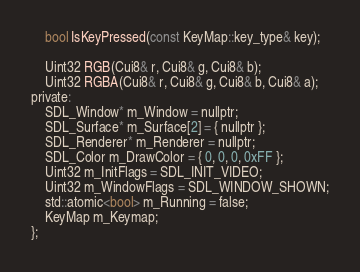Convert code to text. <code><loc_0><loc_0><loc_500><loc_500><_C_>
	bool IsKeyPressed(const KeyMap::key_type& key);

	Uint32 RGB(Cui8& r, Cui8& g, Cui8& b);
	Uint32 RGBA(Cui8& r, Cui8& g, Cui8& b, Cui8& a);
private:
	SDL_Window* m_Window = nullptr;
	SDL_Surface* m_Surface[2] = { nullptr };
	SDL_Renderer* m_Renderer = nullptr;
	SDL_Color m_DrawColor = { 0, 0, 0, 0xFF };
	Uint32 m_InitFlags = SDL_INIT_VIDEO;
	Uint32 m_WindowFlags = SDL_WINDOW_SHOWN;
	std::atomic<bool> m_Running = false;
	KeyMap m_Keymap;
};
</code> 